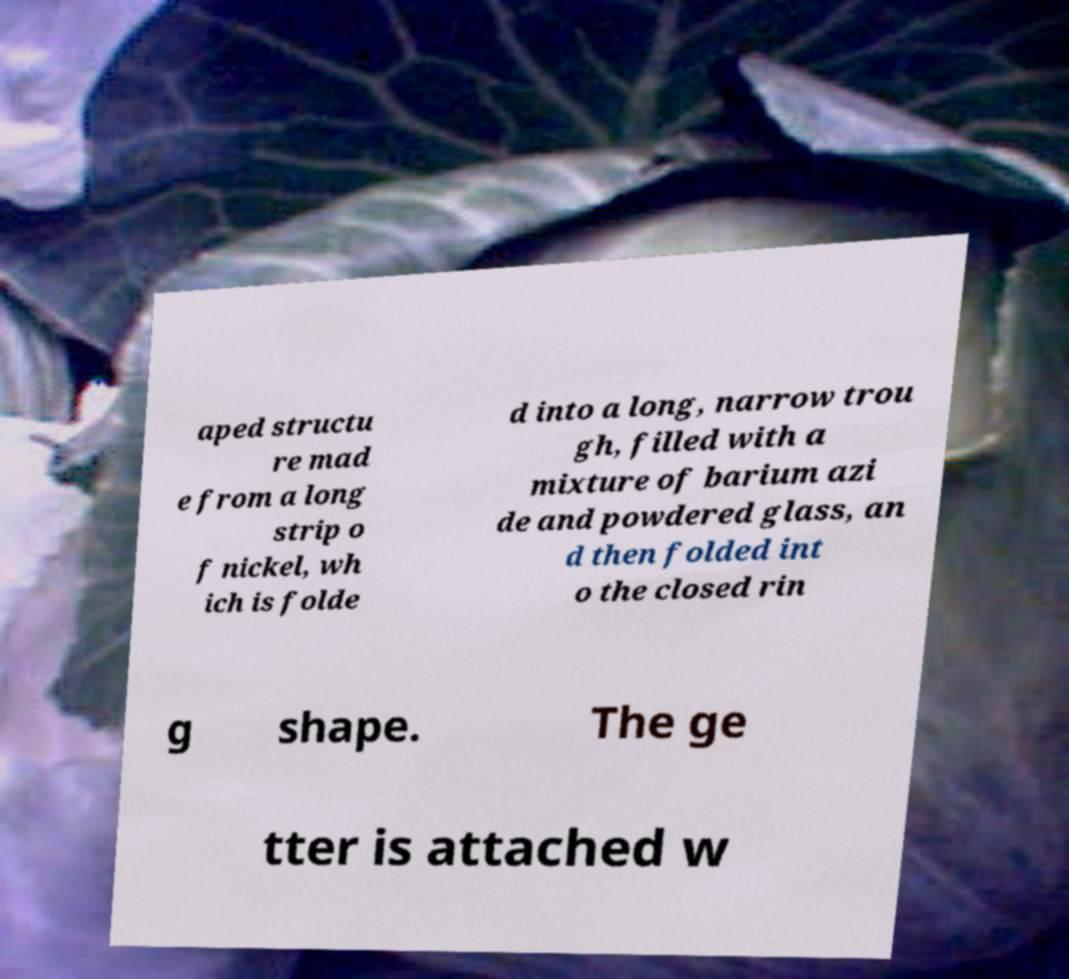I need the written content from this picture converted into text. Can you do that? aped structu re mad e from a long strip o f nickel, wh ich is folde d into a long, narrow trou gh, filled with a mixture of barium azi de and powdered glass, an d then folded int o the closed rin g shape. The ge tter is attached w 